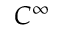<formula> <loc_0><loc_0><loc_500><loc_500>C ^ { \infty }</formula> 